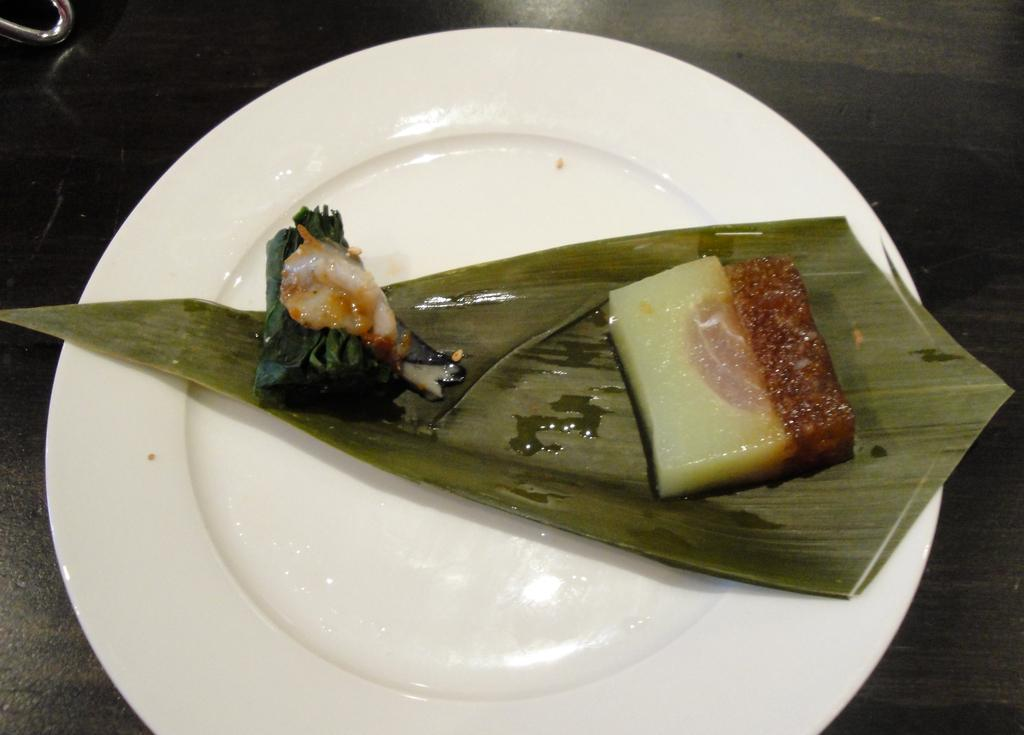What is present on the plate in the picture? There is a food item on the plate. Can you describe the food item on the plate? Unfortunately, the specific food item cannot be determined from the provided facts. How many sticks are used to push the plate in the image? There are no sticks or pushing motion present in the image; it only features a plate with a food item on it. 